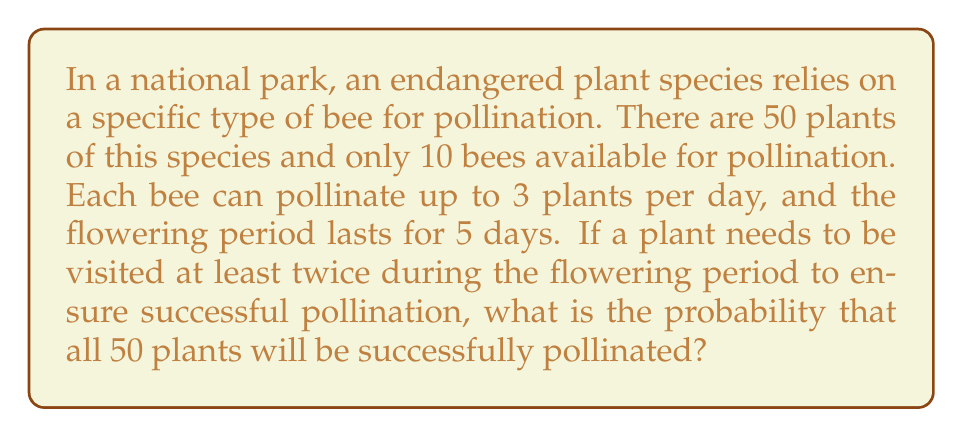Show me your answer to this math problem. Let's approach this step-by-step:

1) First, calculate the total number of plant visits possible:
   $$ \text{Total visits} = 10 \text{ bees} \times 3 \text{ plants/day} \times 5 \text{ days} = 150 \text{ visits} $$

2) Each plant needs at least 2 visits, so the minimum number of visits required for all plants:
   $$ \text{Minimum visits needed} = 50 \text{ plants} \times 2 \text{ visits/plant} = 100 \text{ visits} $$

3) The problem can be modeled as a binomial distribution, where each plant has a probability of being successfully pollinated (visited at least twice).

4) To calculate this probability for a single plant:
   - Probability of not being visited: $p_0 = \left(\frac{49}{50}\right)^{150} \approx 0.0498$
   - Probability of being visited once: $p_1 = 150 \times \frac{1}{50} \times \left(\frac{49}{50}\right)^{149} \approx 0.1507$
   - Probability of being visited at least twice: $p_{\geq 2} = 1 - p_0 - p_1 \approx 0.7995$

5) For all 50 plants to be successfully pollinated, each plant must be visited at least twice. The probability of this occurring is:
   $$ P(\text{all plants pollinated}) = (p_{\geq 2})^{50} \approx (0.7995)^{50} \approx 4.38 \times 10^{-5} $$

6) Convert to a percentage:
   $$ 4.38 \times 10^{-5} \times 100\% \approx 0.00438\% $$
Answer: $0.00438\%$ 